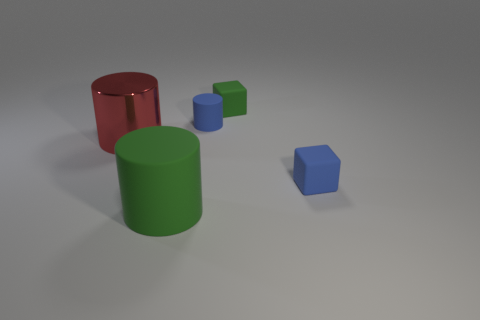What number of other objects are there of the same shape as the big metal thing?
Offer a very short reply. 2. The other tiny object that is the same shape as the small green thing is what color?
Keep it short and to the point. Blue. What size is the green cylinder?
Provide a short and direct response. Large. What number of balls are green things or big metallic things?
Provide a succinct answer. 0. What is the size of the other blue thing that is the same shape as the metal thing?
Keep it short and to the point. Small. What number of purple matte blocks are there?
Your answer should be compact. 0. Do the metallic object and the blue rubber thing in front of the large red metallic cylinder have the same shape?
Offer a terse response. No. What is the size of the green object in front of the small green rubber object?
Your answer should be very brief. Large. What material is the small cylinder?
Your answer should be very brief. Rubber. Does the large object that is behind the large green matte cylinder have the same shape as the small green thing?
Provide a short and direct response. No. 